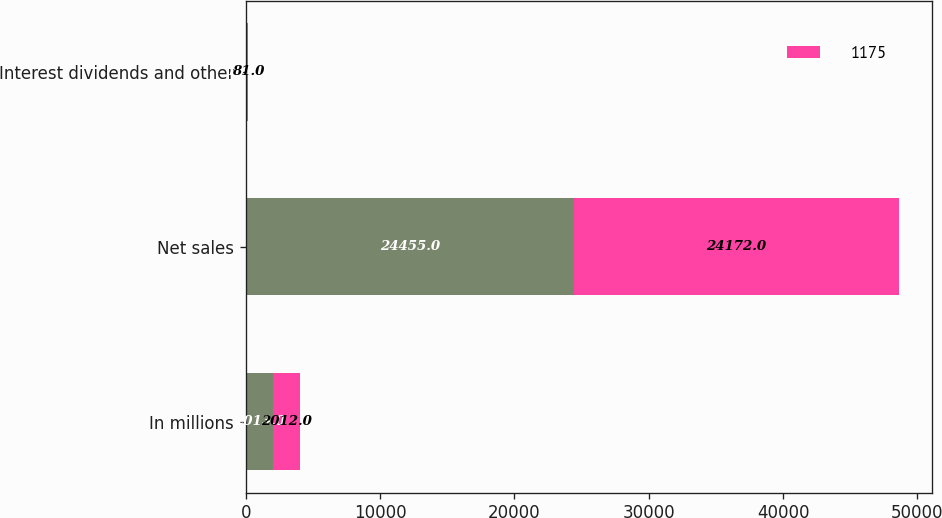Convert chart to OTSL. <chart><loc_0><loc_0><loc_500><loc_500><stacked_bar_chart><ecel><fcel>In millions<fcel>Net sales<fcel>Interest dividends and other<nl><fcel>nan<fcel>2013<fcel>24455<fcel>106<nl><fcel>1175<fcel>2012<fcel>24172<fcel>81<nl></chart> 